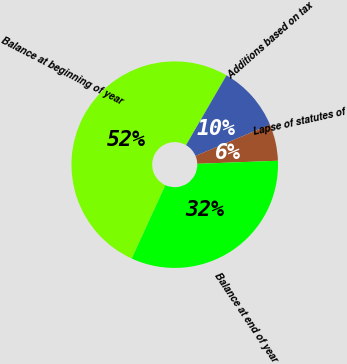Convert chart. <chart><loc_0><loc_0><loc_500><loc_500><pie_chart><fcel>Balance at beginning of year<fcel>Additions based on tax<fcel>Lapse of statutes of<fcel>Balance at end of year<nl><fcel>51.53%<fcel>10.31%<fcel>5.73%<fcel>32.44%<nl></chart> 